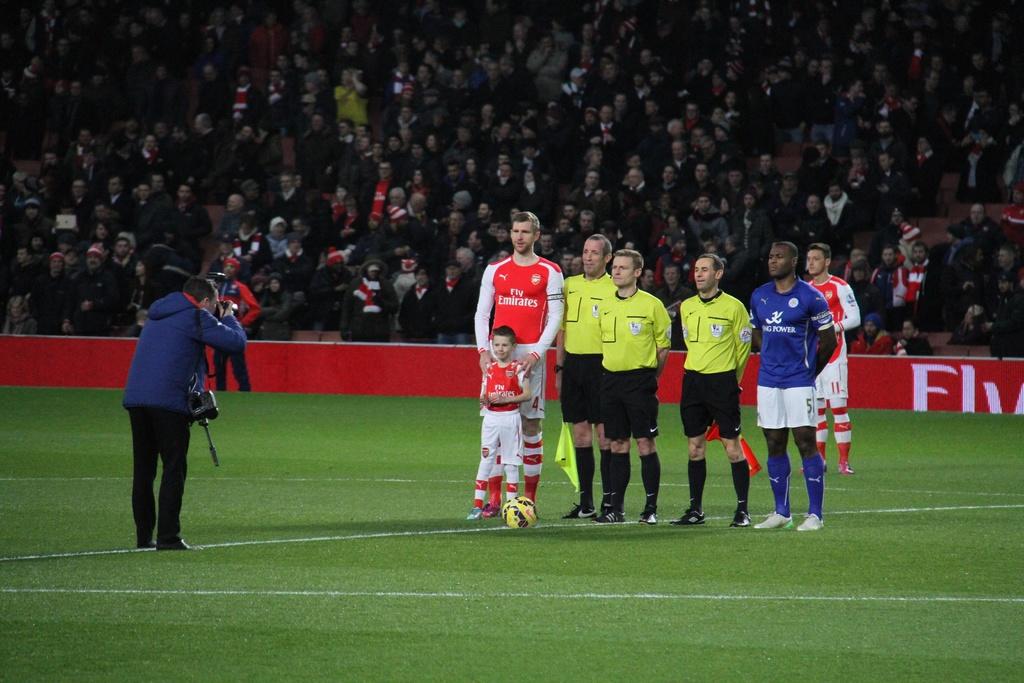Which company is sponsoring the team in red jersey?
Offer a terse response. Emirates. 